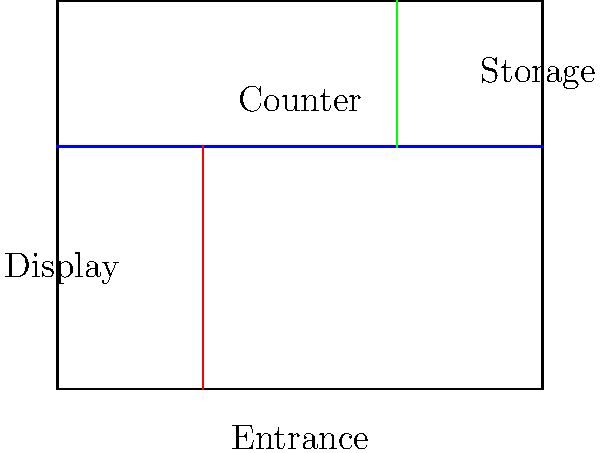You are planning to optimize the layout of your flower shop. Given the floor plan above, where should you place the display area for imported roses to maximize customer visibility and sales? To optimize the layout for displaying imported roses, we should consider the following factors:

1. Customer flow: Customers typically enter from the main entrance and move towards the counter.
2. Visibility: The display should be easily visible to customers as they enter and move through the shop.
3. Accessibility: Customers should be able to browse and interact with the display comfortably.
4. Proximity to counter: Having the display near the counter allows for easy assistance and encourages impulse purchases.

Analyzing the floor plan:
1. The entrance is at the bottom of the diagram.
2. The counter runs horizontally across the middle of the shop.
3. There's a vertical section on the left side of the shop, currently labeled as "Display".
4. A storage area is located at the top right corner.

The best location for the imported roses display would be the area labeled "Display" on the left side of the shop because:

1. It's immediately visible to customers as they enter the shop.
2. Customers can easily access and browse the display as they move towards the counter.
3. It's close to the counter, allowing staff to provide information and assistance.
4. This location creates a natural flow, guiding customers from the entrance, past the display, to the counter.
Answer: Left side of the shop, between the entrance and counter 